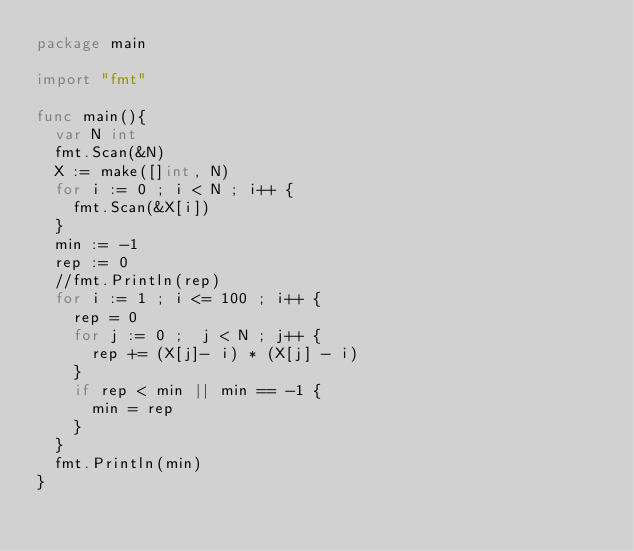<code> <loc_0><loc_0><loc_500><loc_500><_Go_>package main

import "fmt"

func main(){
	var N int
	fmt.Scan(&N)
	X := make([]int, N)
	for i := 0 ; i < N ; i++ {
		fmt.Scan(&X[i])
	}
	min := -1
	rep := 0
	//fmt.Println(rep)
	for i := 1 ; i <= 100 ; i++ {
		rep = 0
		for j := 0 ;  j < N ; j++ {
			rep += (X[j]- i) * (X[j] - i)
		}
		if rep < min || min == -1 {
			min = rep
		}
	}
	fmt.Println(min)
}</code> 